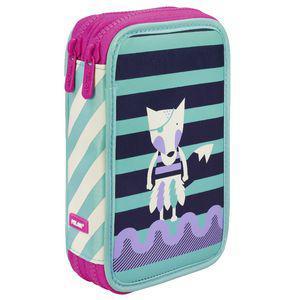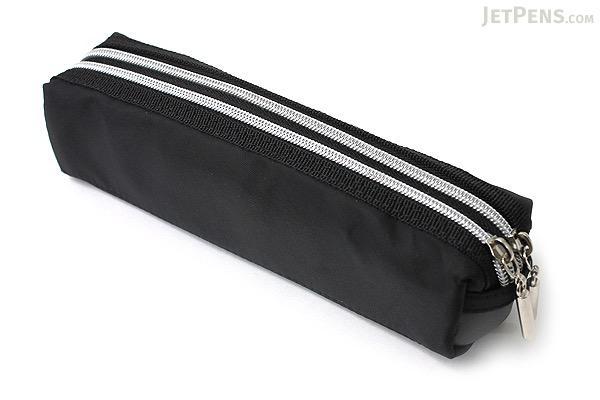The first image is the image on the left, the second image is the image on the right. Given the left and right images, does the statement "An image shows just one pencil case, and it is solid sky blue in color." hold true? Answer yes or no. No. The first image is the image on the left, the second image is the image on the right. Considering the images on both sides, is "There is a single oblong, black rectangular case with no visible logo on it." valid? Answer yes or no. Yes. 